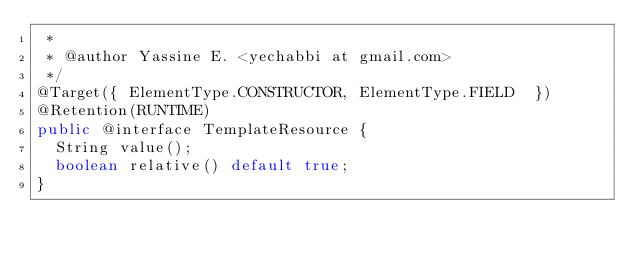<code> <loc_0><loc_0><loc_500><loc_500><_Java_> *
 * @author Yassine E. <yechabbi at gmail.com>
 */
@Target({ ElementType.CONSTRUCTOR, ElementType.FIELD  })
@Retention(RUNTIME)
public @interface TemplateResource {
  String value();
  boolean relative() default true;
}
</code> 